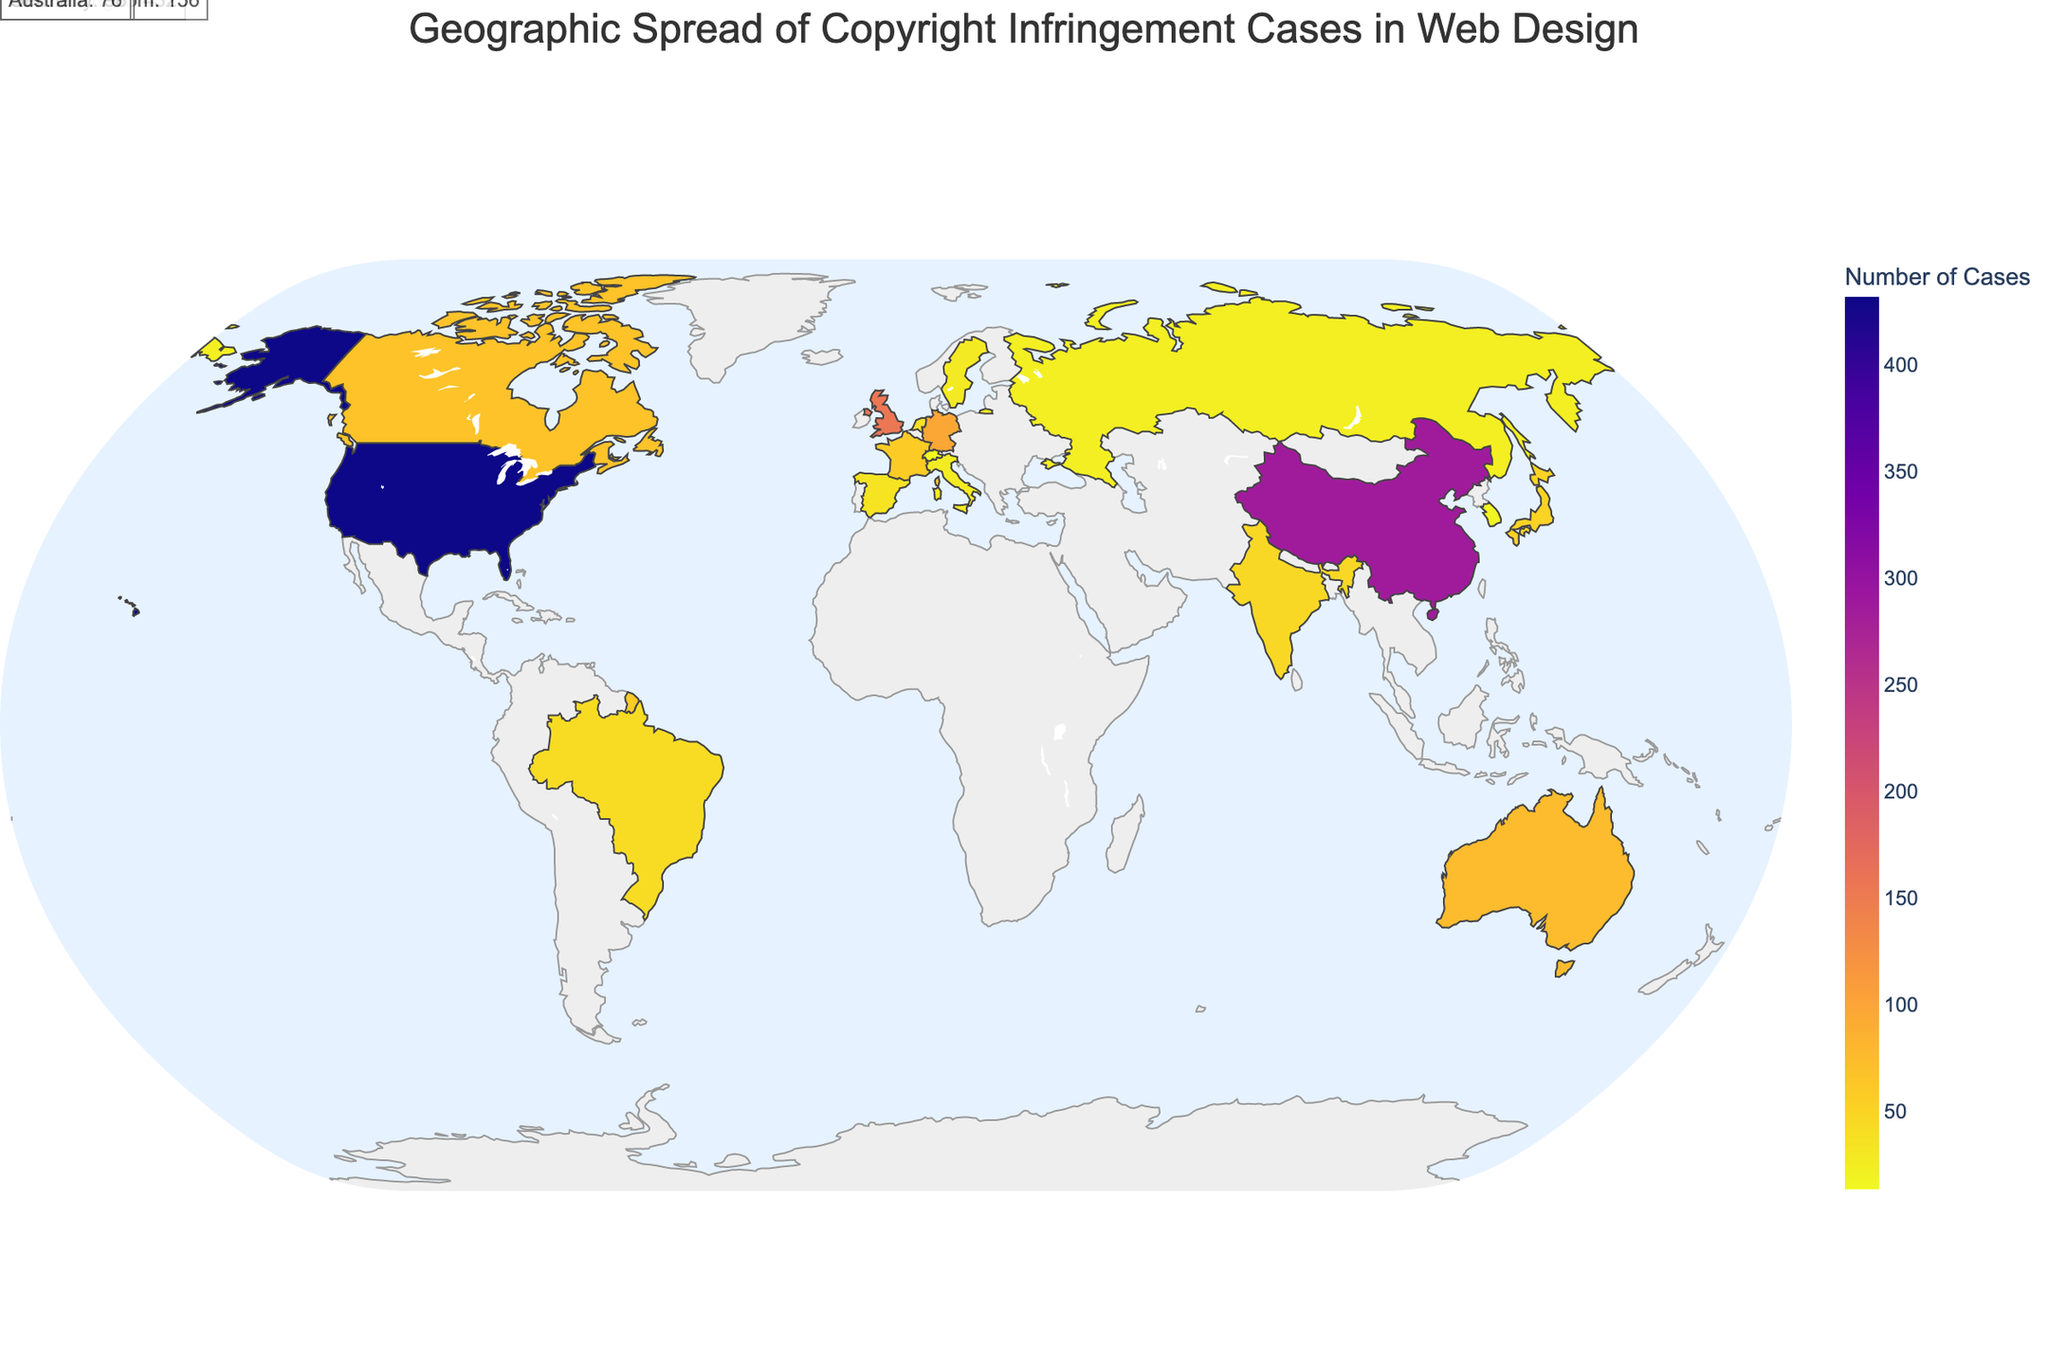How many copyright infringement cases are there in the United States? The visual representation shows the data for the number of cases per country. By looking at the United States on the map, the figure indicates 432 cases for the United States.
Answer: 432 Which country has the second-highest number of copyright infringement cases? The figure shows a list of countries color-coded according to the number of cases. China is the country with the second-highest number, as indicated by a different shade of color representing 287 cases.
Answer: China What is the total percentage of copyright infringement cases for the top three countries combined? The top three countries by number of cases are the United States (28.5%), China (18.9%), and the United Kingdom (10.3%). Adding these percentages gives 28.5 + 18.9 + 10.3 = 57.7%.
Answer: 57.7% Which country has fewer copyright infringement cases: Germany or Australia? The figure lists Germany with 98 cases and Australia with 76 cases. Thus, Australia has fewer cases.
Answer: Australia What is the visual appearance of the ocean and the land on the map? The oceans are colored light blue, and the land areas are colored light gray. This information can be directly observed from the visual representation of the plot.
Answer: Oceans are light blue, and land is light gray How many countries have more than 50 copyright infringement cases? The figure lists the number of cases for each country. The countries with more than 50 cases are the United States, China, United Kingdom, Germany, Australia, Canada, France, Japan, and India. Counting these gives a total of 9 countries.
Answer: 9 Which country has a higher percentage of global total cases: Japan or Brazil? By examining the figure, Japan has 3.4% of the global total while Brazil has 2.8%. Therefore, Japan has a higher percentage.
Answer: Japan What is the sum of copyright infringement cases for France, Japan, and India? The number of cases for each country is: France (59), Japan (52), and India (47). Adding these gives 59 + 52 + 47 = 158 cases.
Answer: 158 What is the rank of Spain in terms of the number of copyright infringement cases? Spain is listed with 35 cases in the figure, and observing the other data points, it is the 12th highest.
Answer: 12th What annotation can you observe for the country with the highest number of copyright infringement cases? The annotation for the United States, which has the highest number of cases, reads "United States: 432". This annotation can be seen directly on the figure.
Answer: United States: 432 